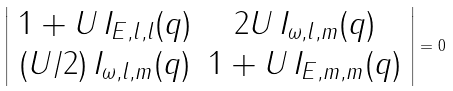Convert formula to latex. <formula><loc_0><loc_0><loc_500><loc_500>\left | \begin{array} { c c } 1 + U \, I _ { E , l , l } ( q ) & 2 U \, I _ { \omega , l , m } ( q ) \\ ( U / 2 ) \, I _ { \omega , l , m } ( q ) & 1 + U \, I _ { E , m , m } ( q ) \end{array} \right | = 0</formula> 